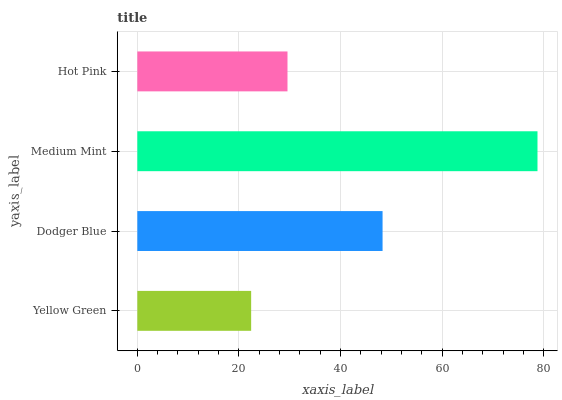Is Yellow Green the minimum?
Answer yes or no. Yes. Is Medium Mint the maximum?
Answer yes or no. Yes. Is Dodger Blue the minimum?
Answer yes or no. No. Is Dodger Blue the maximum?
Answer yes or no. No. Is Dodger Blue greater than Yellow Green?
Answer yes or no. Yes. Is Yellow Green less than Dodger Blue?
Answer yes or no. Yes. Is Yellow Green greater than Dodger Blue?
Answer yes or no. No. Is Dodger Blue less than Yellow Green?
Answer yes or no. No. Is Dodger Blue the high median?
Answer yes or no. Yes. Is Hot Pink the low median?
Answer yes or no. Yes. Is Yellow Green the high median?
Answer yes or no. No. Is Medium Mint the low median?
Answer yes or no. No. 